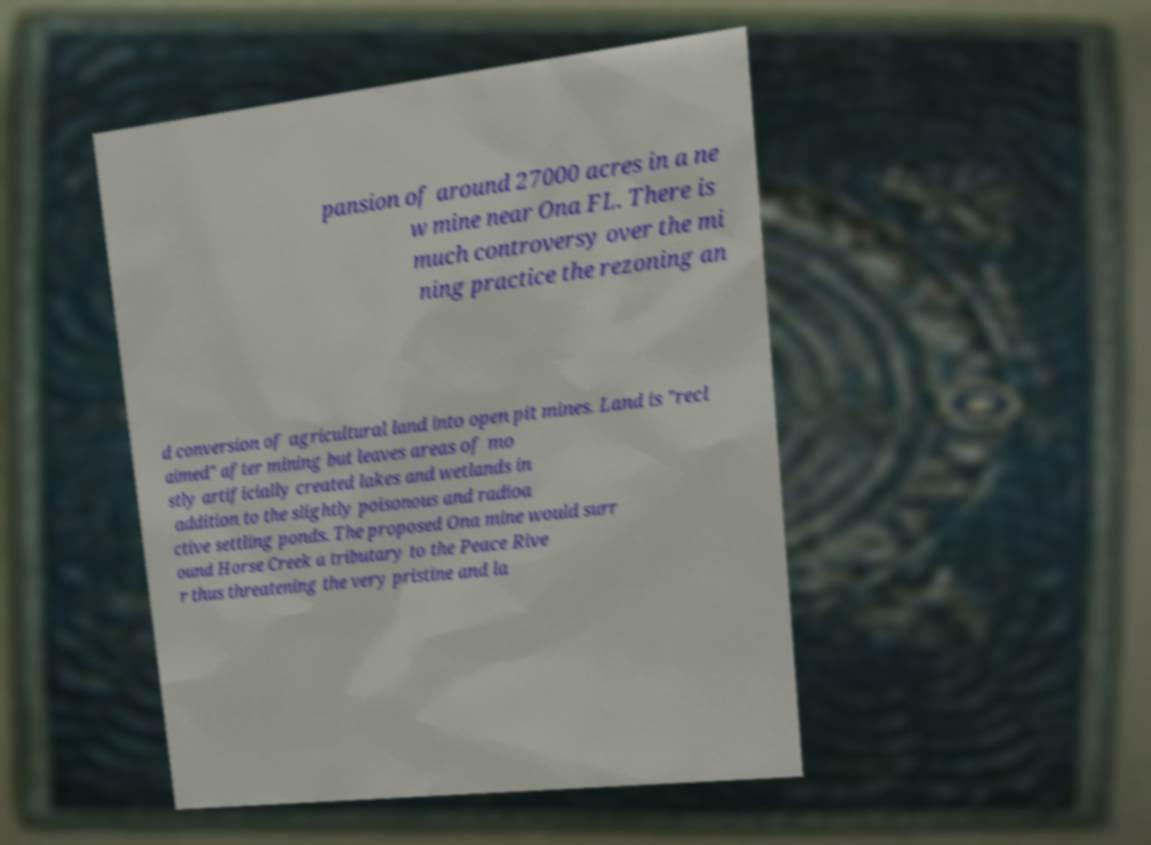Could you extract and type out the text from this image? pansion of around 27000 acres in a ne w mine near Ona FL. There is much controversy over the mi ning practice the rezoning an d conversion of agricultural land into open pit mines. Land is "recl aimed" after mining but leaves areas of mo stly artificially created lakes and wetlands in addition to the slightly poisonous and radioa ctive settling ponds. The proposed Ona mine would surr ound Horse Creek a tributary to the Peace Rive r thus threatening the very pristine and la 